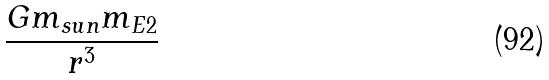Convert formula to latex. <formula><loc_0><loc_0><loc_500><loc_500>\frac { G m _ { s u n } m _ { E 2 } } { r ^ { 3 } }</formula> 